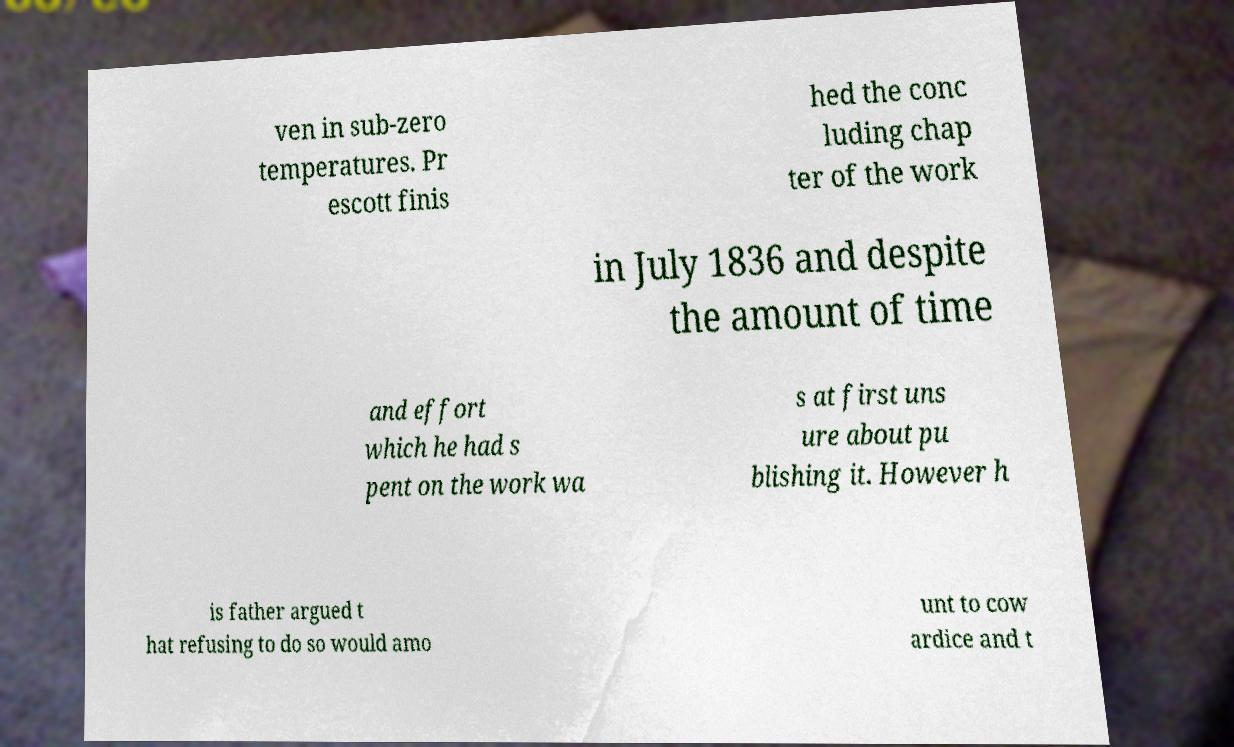Please identify and transcribe the text found in this image. ven in sub-zero temperatures. Pr escott finis hed the conc luding chap ter of the work in July 1836 and despite the amount of time and effort which he had s pent on the work wa s at first uns ure about pu blishing it. However h is father argued t hat refusing to do so would amo unt to cow ardice and t 